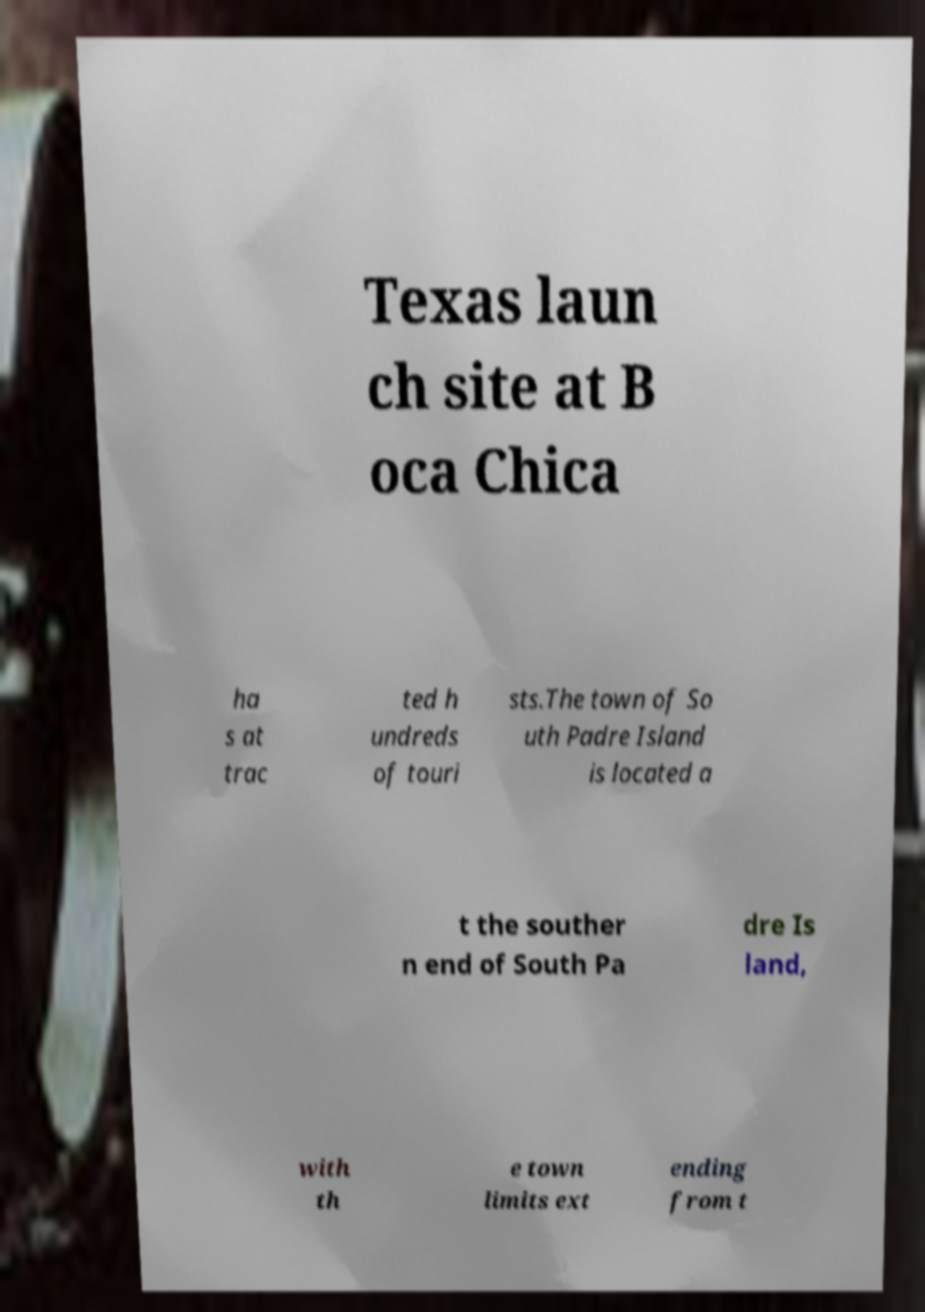Could you assist in decoding the text presented in this image and type it out clearly? Texas laun ch site at B oca Chica ha s at trac ted h undreds of touri sts.The town of So uth Padre Island is located a t the souther n end of South Pa dre Is land, with th e town limits ext ending from t 